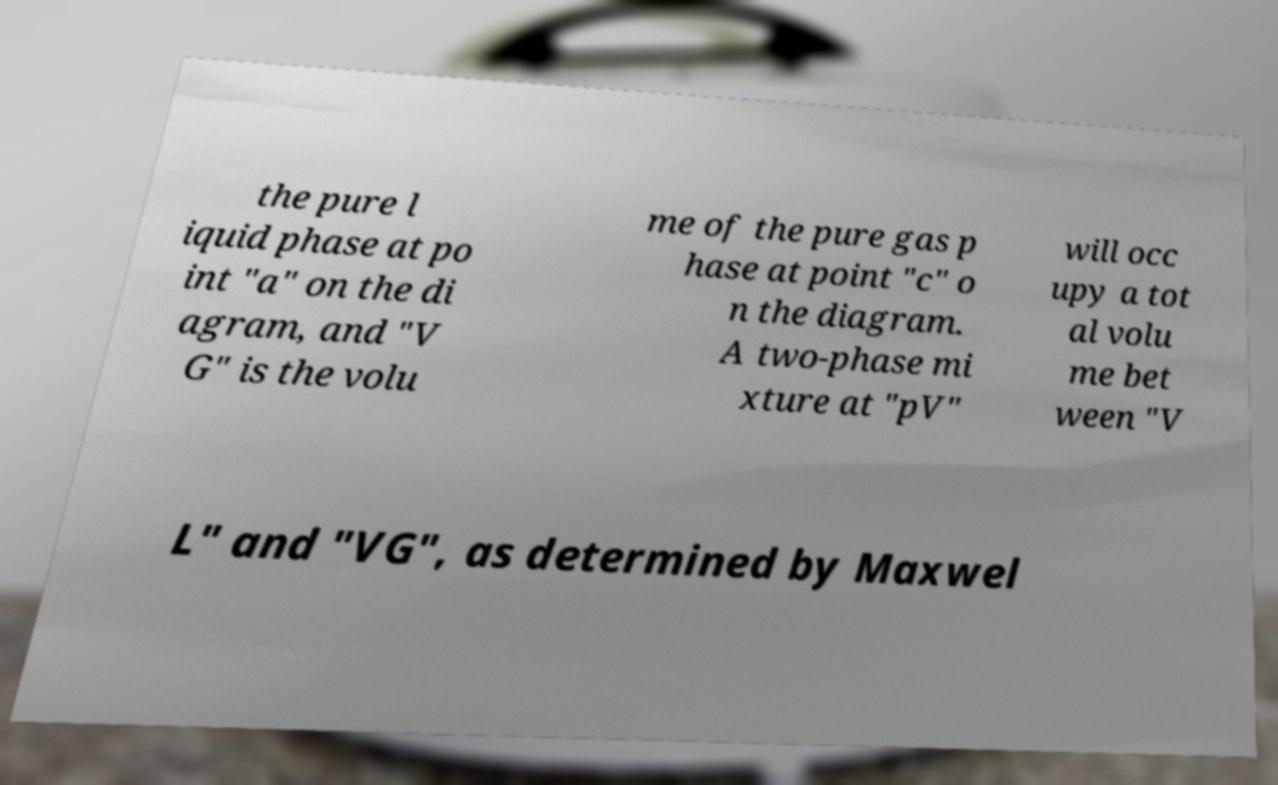Please read and relay the text visible in this image. What does it say? the pure l iquid phase at po int "a" on the di agram, and "V G" is the volu me of the pure gas p hase at point "c" o n the diagram. A two-phase mi xture at "pV" will occ upy a tot al volu me bet ween "V L" and "VG", as determined by Maxwel 